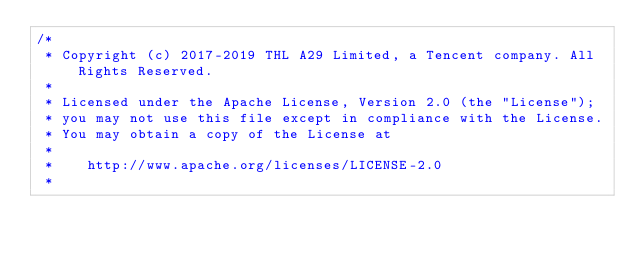<code> <loc_0><loc_0><loc_500><loc_500><_C++_>/*
 * Copyright (c) 2017-2019 THL A29 Limited, a Tencent company. All Rights Reserved.
 *
 * Licensed under the Apache License, Version 2.0 (the "License");
 * you may not use this file except in compliance with the License.
 * You may obtain a copy of the License at
 *
 *    http://www.apache.org/licenses/LICENSE-2.0
 *</code> 